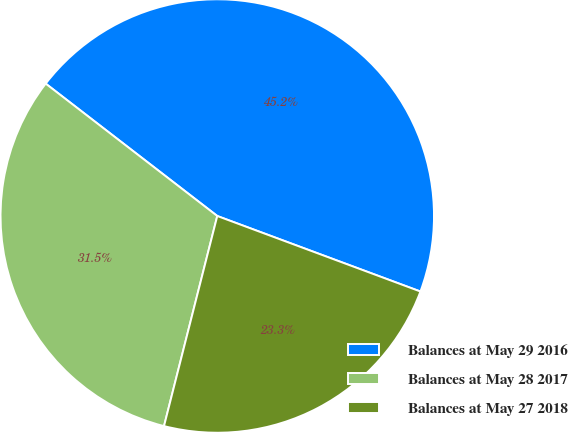<chart> <loc_0><loc_0><loc_500><loc_500><pie_chart><fcel>Balances at May 29 2016<fcel>Balances at May 28 2017<fcel>Balances at May 27 2018<nl><fcel>45.21%<fcel>31.51%<fcel>23.29%<nl></chart> 